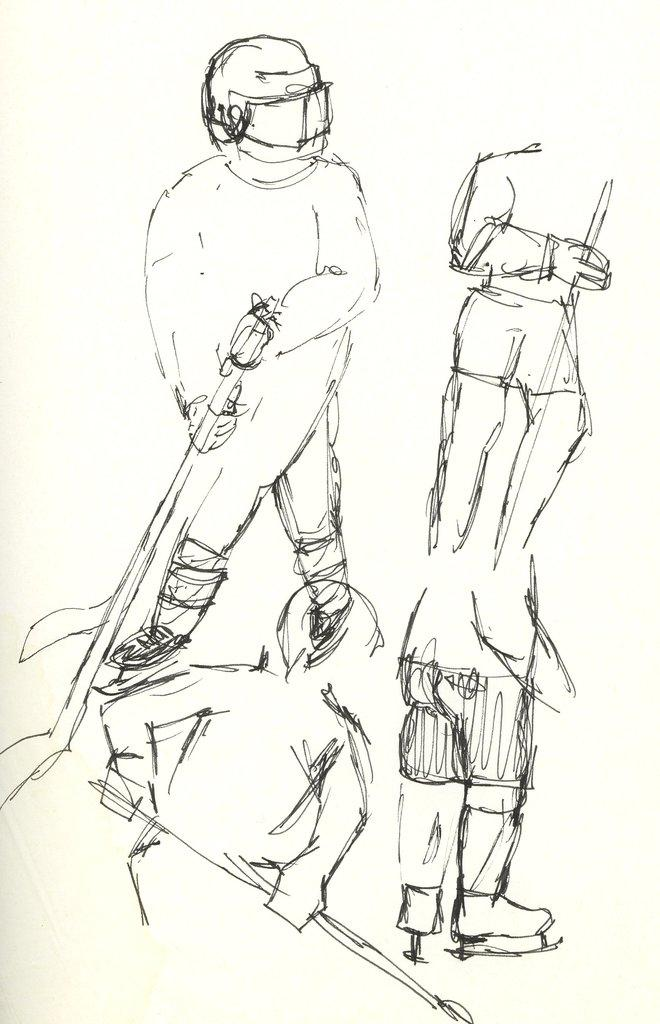What is the main subject of the image? The main subject of the image is a sketch. What does the sketch depict? The sketch depicts people. What are the people in the sketch doing? The people in the sketch are holding an object in their hand. What type of star can be seen in the image? There is no star present in the image; it features a sketch of people holding an object. What kind of wheel is visible in the image? There is no wheel present in the image; it features a sketch of people holding an object. 